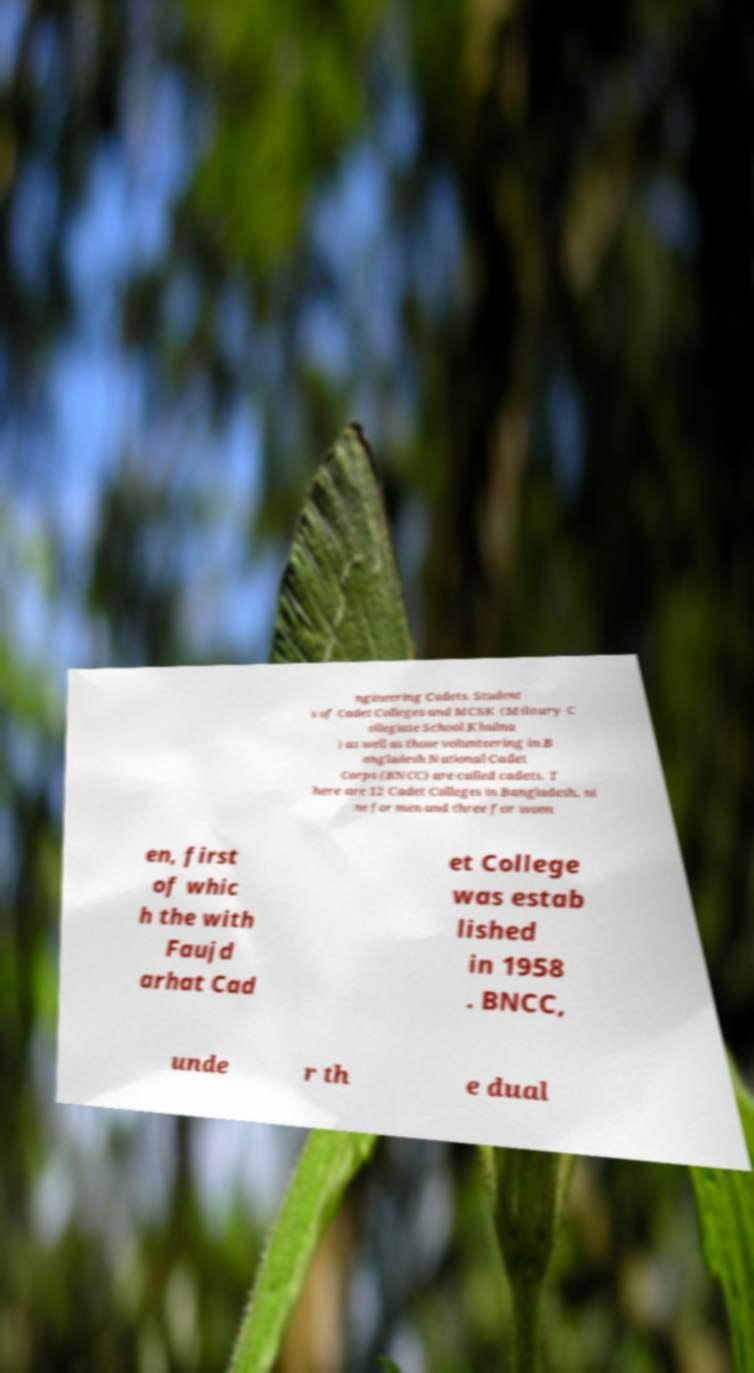I need the written content from this picture converted into text. Can you do that? ngineering Cadets. Student s of Cadet Colleges and MCSK (Military C ollegiate School Khulna ) as well as those volunteering in B angladesh National Cadet Corps (BNCC) are called cadets. T here are 12 Cadet Colleges in Bangladesh, ni ne for men and three for wom en, first of whic h the with Faujd arhat Cad et College was estab lished in 1958 . BNCC, unde r th e dual 